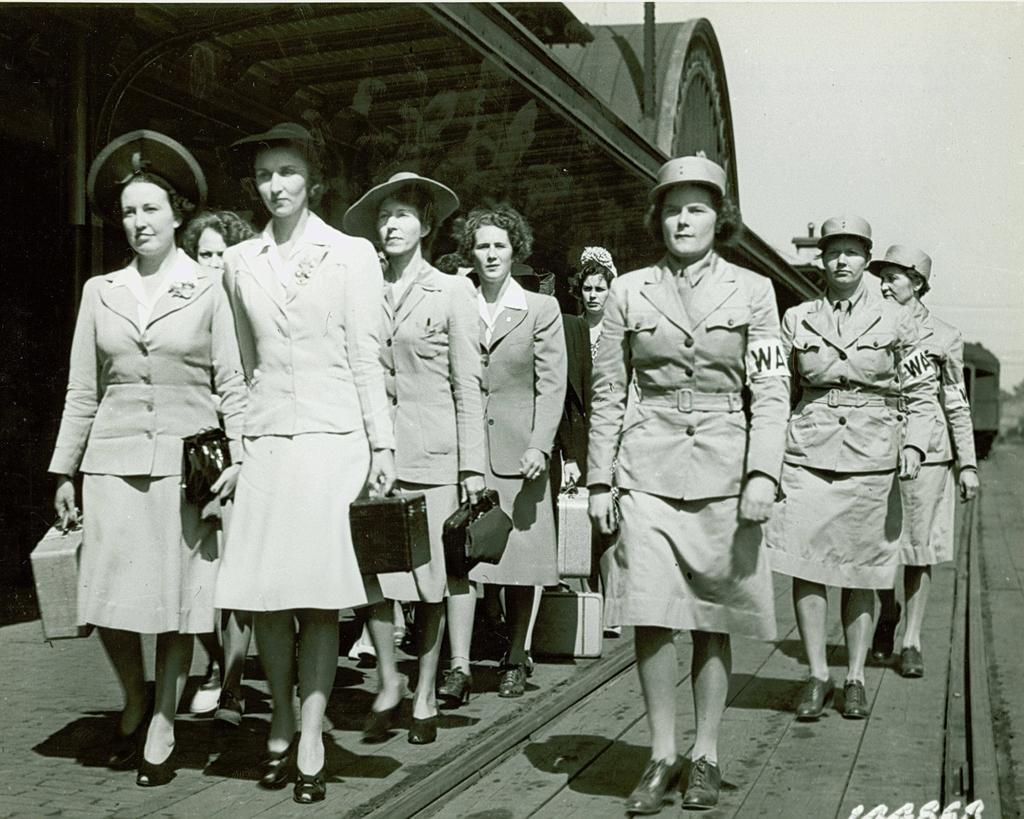Please provide a concise description of this image. In this image we can see a group of lady are standing. On the right side of the image we can see some ladies are wearing the same type of dress and holding bags in their hands. On the left side of the image we can see three ladies are standing in line and wore the same type of dress. 